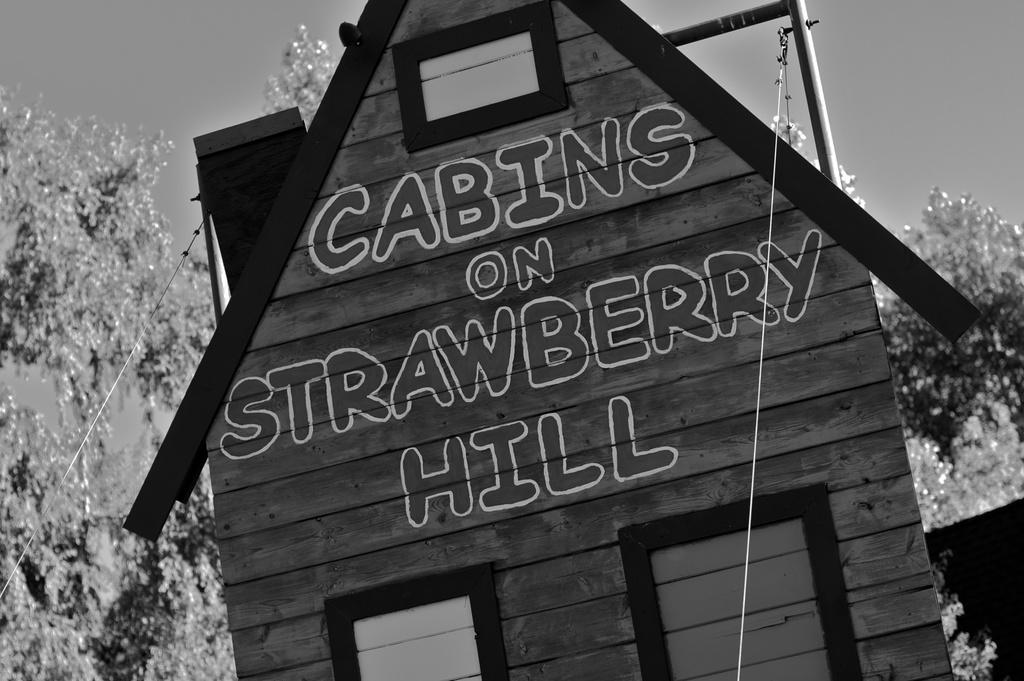What is the color scheme of the image? The image is black and white. What is the main subject in the center of the image? There is a building in the center of the image. What type of natural elements can be seen in the background? There are trees in the background of the image. What type of man-made structures are visible in the foreground? There are cables in the foreground of the image. Can you see a monkey climbing the building in the image? No, there is no monkey present in the image. What type of metal is used to construct the building in the image? The image is black and white, so it is not possible to determine the type of metal used in the construction of the building. 